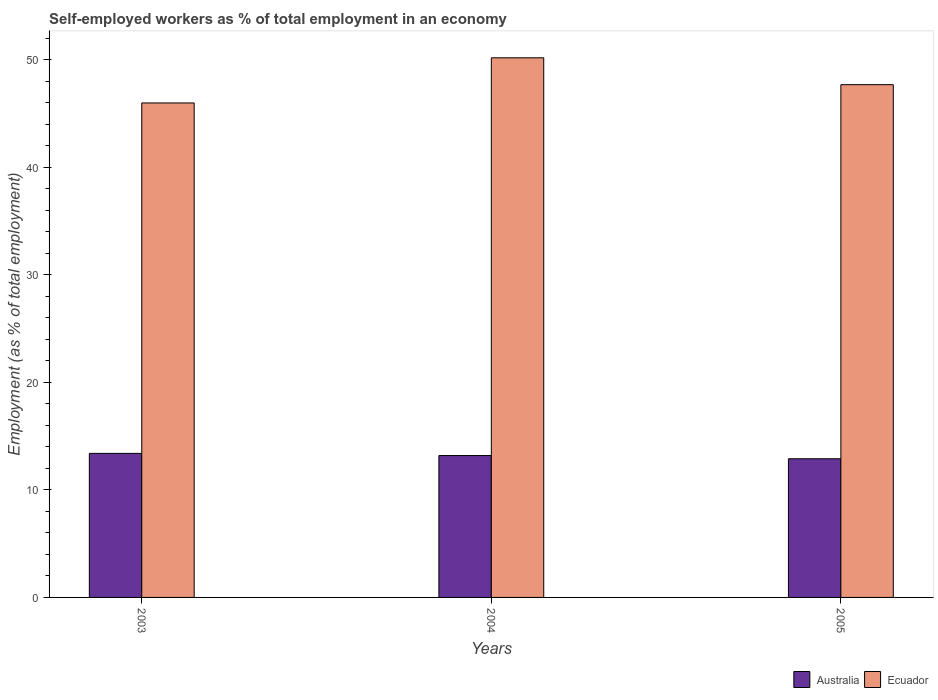How many groups of bars are there?
Offer a terse response. 3. Are the number of bars on each tick of the X-axis equal?
Provide a short and direct response. Yes. What is the label of the 2nd group of bars from the left?
Provide a short and direct response. 2004. In how many cases, is the number of bars for a given year not equal to the number of legend labels?
Keep it short and to the point. 0. What is the percentage of self-employed workers in Ecuador in 2004?
Offer a terse response. 50.2. Across all years, what is the maximum percentage of self-employed workers in Australia?
Keep it short and to the point. 13.4. Across all years, what is the minimum percentage of self-employed workers in Ecuador?
Give a very brief answer. 46. In which year was the percentage of self-employed workers in Australia maximum?
Make the answer very short. 2003. What is the total percentage of self-employed workers in Australia in the graph?
Ensure brevity in your answer.  39.5. What is the difference between the percentage of self-employed workers in Australia in 2003 and that in 2004?
Ensure brevity in your answer.  0.2. What is the difference between the percentage of self-employed workers in Australia in 2003 and the percentage of self-employed workers in Ecuador in 2004?
Make the answer very short. -36.8. What is the average percentage of self-employed workers in Australia per year?
Your answer should be very brief. 13.17. In the year 2005, what is the difference between the percentage of self-employed workers in Ecuador and percentage of self-employed workers in Australia?
Your answer should be very brief. 34.8. What is the ratio of the percentage of self-employed workers in Ecuador in 2003 to that in 2004?
Give a very brief answer. 0.92. Is the difference between the percentage of self-employed workers in Ecuador in 2003 and 2004 greater than the difference between the percentage of self-employed workers in Australia in 2003 and 2004?
Ensure brevity in your answer.  No. What is the difference between the highest and the second highest percentage of self-employed workers in Australia?
Offer a terse response. 0.2. What is the difference between the highest and the lowest percentage of self-employed workers in Ecuador?
Offer a very short reply. 4.2. In how many years, is the percentage of self-employed workers in Ecuador greater than the average percentage of self-employed workers in Ecuador taken over all years?
Keep it short and to the point. 1. Is the sum of the percentage of self-employed workers in Australia in 2003 and 2004 greater than the maximum percentage of self-employed workers in Ecuador across all years?
Offer a very short reply. No. What does the 2nd bar from the left in 2005 represents?
Offer a terse response. Ecuador. What does the 1st bar from the right in 2003 represents?
Provide a short and direct response. Ecuador. How many bars are there?
Ensure brevity in your answer.  6. Are all the bars in the graph horizontal?
Your answer should be compact. No. How many years are there in the graph?
Your answer should be compact. 3. Are the values on the major ticks of Y-axis written in scientific E-notation?
Your response must be concise. No. Does the graph contain any zero values?
Your response must be concise. No. Does the graph contain grids?
Your response must be concise. No. What is the title of the graph?
Give a very brief answer. Self-employed workers as % of total employment in an economy. Does "Marshall Islands" appear as one of the legend labels in the graph?
Provide a short and direct response. No. What is the label or title of the X-axis?
Keep it short and to the point. Years. What is the label or title of the Y-axis?
Your answer should be very brief. Employment (as % of total employment). What is the Employment (as % of total employment) in Australia in 2003?
Your answer should be very brief. 13.4. What is the Employment (as % of total employment) of Australia in 2004?
Provide a succinct answer. 13.2. What is the Employment (as % of total employment) in Ecuador in 2004?
Provide a succinct answer. 50.2. What is the Employment (as % of total employment) in Australia in 2005?
Provide a short and direct response. 12.9. What is the Employment (as % of total employment) of Ecuador in 2005?
Provide a short and direct response. 47.7. Across all years, what is the maximum Employment (as % of total employment) of Australia?
Your answer should be compact. 13.4. Across all years, what is the maximum Employment (as % of total employment) in Ecuador?
Provide a short and direct response. 50.2. Across all years, what is the minimum Employment (as % of total employment) in Australia?
Provide a short and direct response. 12.9. What is the total Employment (as % of total employment) in Australia in the graph?
Provide a succinct answer. 39.5. What is the total Employment (as % of total employment) of Ecuador in the graph?
Your answer should be very brief. 143.9. What is the difference between the Employment (as % of total employment) of Ecuador in 2003 and that in 2004?
Your answer should be compact. -4.2. What is the difference between the Employment (as % of total employment) of Australia in 2003 and that in 2005?
Ensure brevity in your answer.  0.5. What is the difference between the Employment (as % of total employment) in Ecuador in 2003 and that in 2005?
Keep it short and to the point. -1.7. What is the difference between the Employment (as % of total employment) of Australia in 2004 and that in 2005?
Your answer should be compact. 0.3. What is the difference between the Employment (as % of total employment) in Australia in 2003 and the Employment (as % of total employment) in Ecuador in 2004?
Ensure brevity in your answer.  -36.8. What is the difference between the Employment (as % of total employment) in Australia in 2003 and the Employment (as % of total employment) in Ecuador in 2005?
Offer a terse response. -34.3. What is the difference between the Employment (as % of total employment) in Australia in 2004 and the Employment (as % of total employment) in Ecuador in 2005?
Offer a terse response. -34.5. What is the average Employment (as % of total employment) of Australia per year?
Offer a terse response. 13.17. What is the average Employment (as % of total employment) in Ecuador per year?
Offer a terse response. 47.97. In the year 2003, what is the difference between the Employment (as % of total employment) in Australia and Employment (as % of total employment) in Ecuador?
Provide a short and direct response. -32.6. In the year 2004, what is the difference between the Employment (as % of total employment) in Australia and Employment (as % of total employment) in Ecuador?
Your answer should be very brief. -37. In the year 2005, what is the difference between the Employment (as % of total employment) of Australia and Employment (as % of total employment) of Ecuador?
Offer a very short reply. -34.8. What is the ratio of the Employment (as % of total employment) in Australia in 2003 to that in 2004?
Make the answer very short. 1.02. What is the ratio of the Employment (as % of total employment) in Ecuador in 2003 to that in 2004?
Give a very brief answer. 0.92. What is the ratio of the Employment (as % of total employment) of Australia in 2003 to that in 2005?
Provide a succinct answer. 1.04. What is the ratio of the Employment (as % of total employment) of Ecuador in 2003 to that in 2005?
Your answer should be very brief. 0.96. What is the ratio of the Employment (as % of total employment) of Australia in 2004 to that in 2005?
Provide a short and direct response. 1.02. What is the ratio of the Employment (as % of total employment) of Ecuador in 2004 to that in 2005?
Provide a succinct answer. 1.05. What is the difference between the highest and the second highest Employment (as % of total employment) in Australia?
Keep it short and to the point. 0.2. 